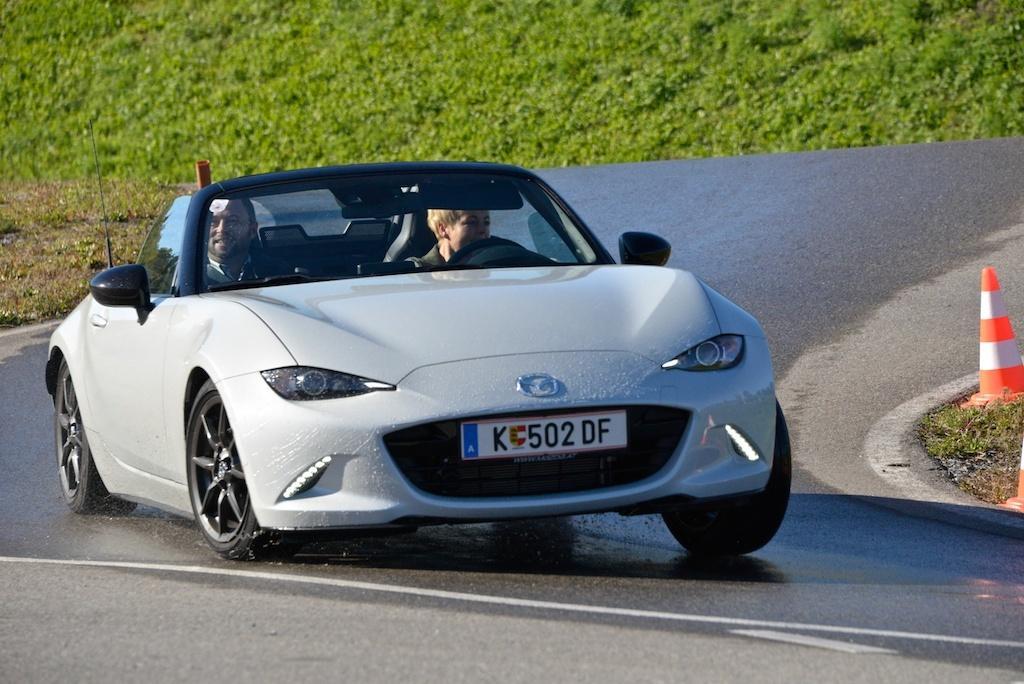Could you give a brief overview of what you see in this image? There are two persons are sitting on a car. On the right side of the person is driving a car. The car has registration number plate and the car has two mirrors. We can see in the background trees,and road. 